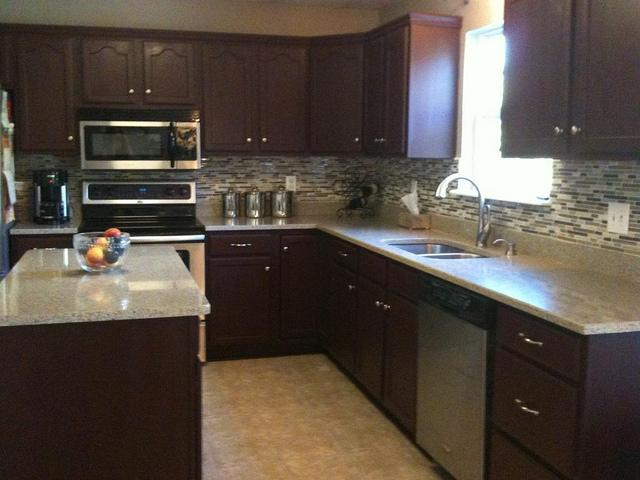The glare from the sun may interfere with a persons ability to do what while cooking?

Choices:
A) touch
B) think
C) smell
D) see see 